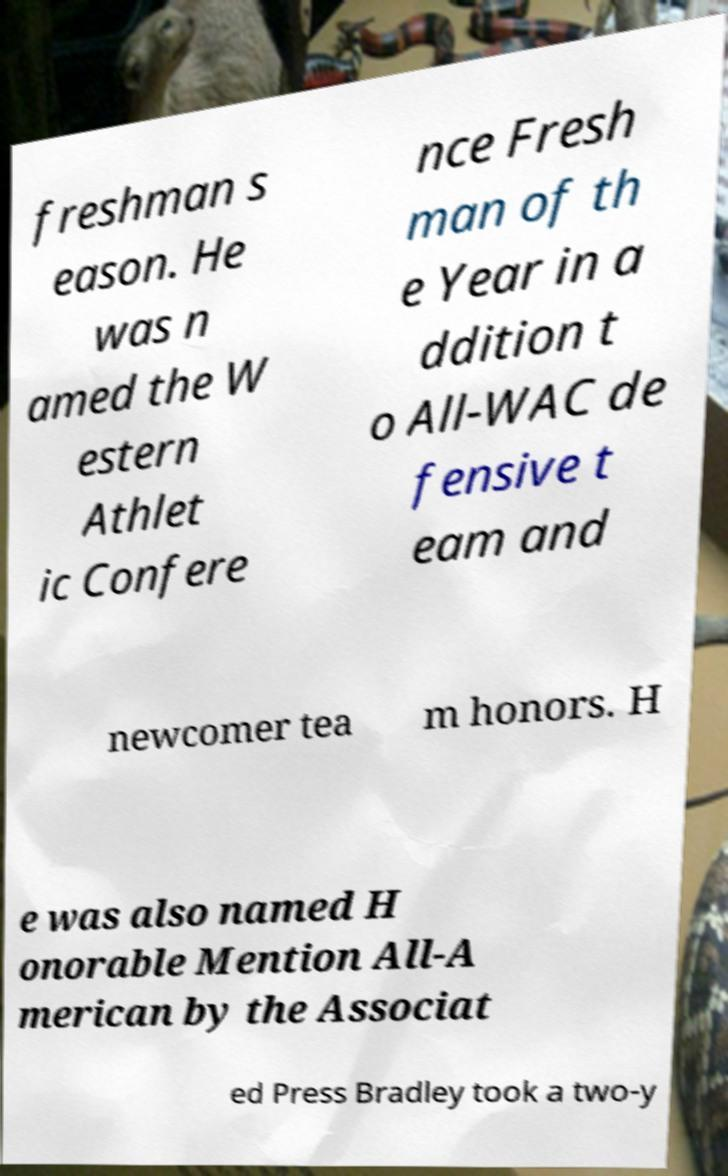Could you assist in decoding the text presented in this image and type it out clearly? freshman s eason. He was n amed the W estern Athlet ic Confere nce Fresh man of th e Year in a ddition t o All-WAC de fensive t eam and newcomer tea m honors. H e was also named H onorable Mention All-A merican by the Associat ed Press Bradley took a two-y 